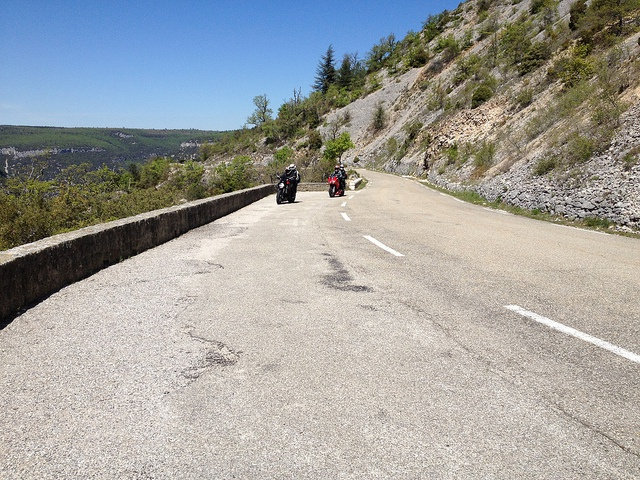Describe the objects in this image and their specific colors. I can see motorcycle in gray, black, lightgray, and darkgray tones, motorcycle in gray, black, maroon, and brown tones, people in gray, black, darkgray, and lightgray tones, people in gray, black, and darkgray tones, and people in gray, black, darkgray, and white tones in this image. 